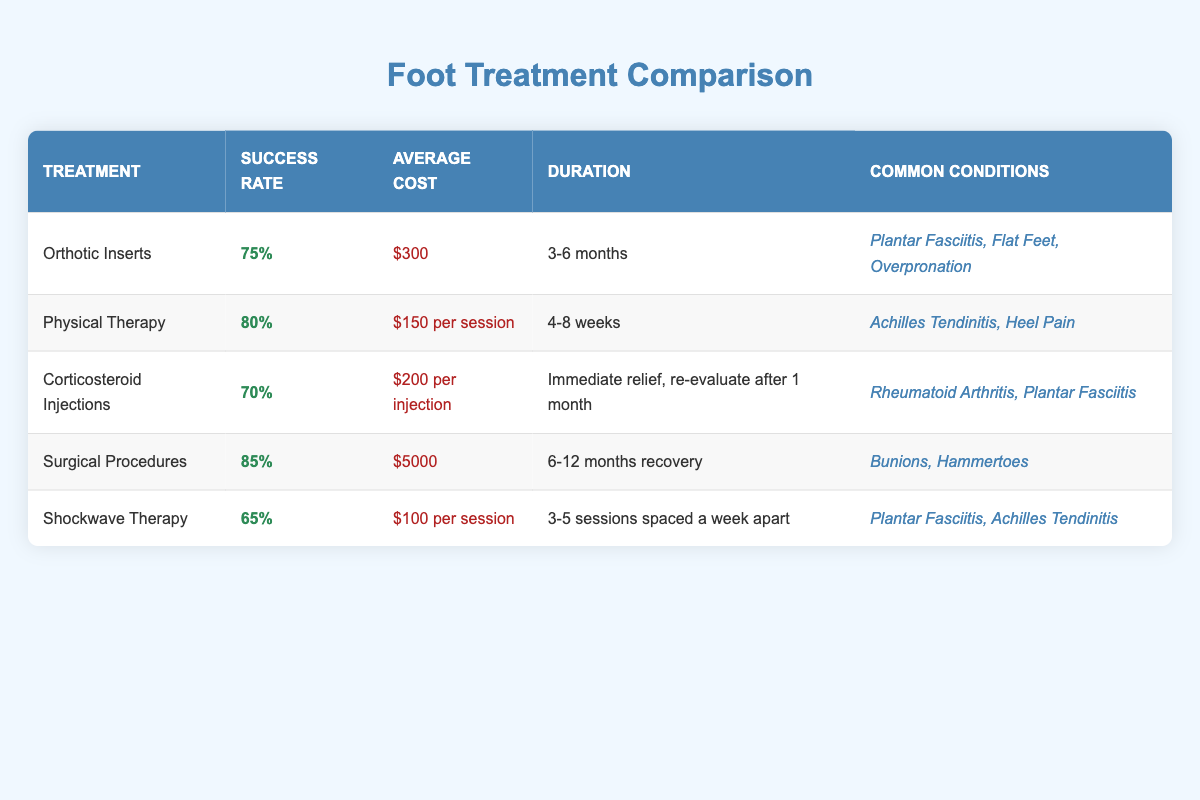What is the success rate of Physical Therapy? Referencing the table, the success rate listed for Physical Therapy is 80%.
Answer: 80% How much does Orthotic Inserts cost on average? The table specifies the average cost for Orthotic Inserts as $300.
Answer: $300 What treatment has the highest success rate? By comparing the success rates provided, Surgical Procedures show the highest success rate at 85%.
Answer: 85% Which treatments are used for Plantar Fasciitis? The table lists Orthotic Inserts, Corticosteroid Injections, and Shockwave Therapy as common treatments for Plantar Fasciitis.
Answer: Orthotic Inserts, Corticosteroid Injections, Shockwave Therapy What is the average cost for Shockwave Therapy? The table indicates that Shockwave Therapy costs $100 per session.
Answer: $100 per session Is the success rate for Surgical Procedures greater than 80%? The table states that the success rate for Surgical Procedures is 85%, which is indeed greater than 80%.
Answer: Yes If I have a budget of $400, which treatments can I afford? Analyzing the costs, Physical Therapy ($150 per session) and Orthotic Inserts ($300) fall within the budget, while Surgical Procedures ($5000) and Corticosteroid Injections ($200 each) exceed it. Therefore, you can afford Physical Therapy or Orthotic Inserts with your budget.
Answer: Physical Therapy, Orthotic Inserts What is the average success rate of all listed treatments? The success rates are: Orthotic Inserts (75%), Physical Therapy (80%), Corticosteroid Injections (70%), Surgical Procedures (85%), and Shockwave Therapy (65%). Adding these gives: 75 + 80 + 70 + 85 + 65 = 375. Dividing by 5 treatments results in an average success rate of 75%.
Answer: 75% Does any treatment have a success rate below 70%? Reviewing the table, Shockwave Therapy has a success rate of 65%, which is below 70%.
Answer: Yes Which treatment takes the longest duration for recovery? From the table, Surgical Procedures have the longest recovery time listed at 6-12 months.
Answer: 6-12 months 